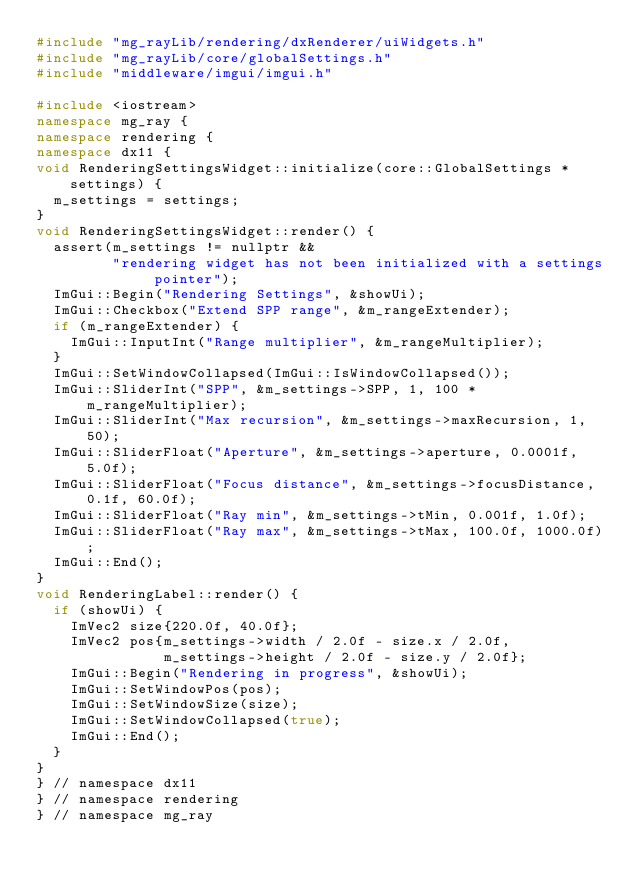<code> <loc_0><loc_0><loc_500><loc_500><_C++_>#include "mg_rayLib/rendering/dxRenderer/uiWidgets.h"
#include "mg_rayLib/core/globalSettings.h"
#include "middleware/imgui/imgui.h"

#include <iostream>
namespace mg_ray {
namespace rendering {
namespace dx11 {
void RenderingSettingsWidget::initialize(core::GlobalSettings *settings) {
  m_settings = settings;
}
void RenderingSettingsWidget::render() {
  assert(m_settings != nullptr &&
         "rendering widget has not been initialized with a settings pointer");
  ImGui::Begin("Rendering Settings", &showUi);
  ImGui::Checkbox("Extend SPP range", &m_rangeExtender);
  if (m_rangeExtender) {
    ImGui::InputInt("Range multiplier", &m_rangeMultiplier);
  }
  ImGui::SetWindowCollapsed(ImGui::IsWindowCollapsed());
  ImGui::SliderInt("SPP", &m_settings->SPP, 1, 100 * m_rangeMultiplier);
  ImGui::SliderInt("Max recursion", &m_settings->maxRecursion, 1, 50);
  ImGui::SliderFloat("Aperture", &m_settings->aperture, 0.0001f, 5.0f);
  ImGui::SliderFloat("Focus distance", &m_settings->focusDistance, 0.1f, 60.0f);
  ImGui::SliderFloat("Ray min", &m_settings->tMin, 0.001f, 1.0f);
  ImGui::SliderFloat("Ray max", &m_settings->tMax, 100.0f, 1000.0f);
  ImGui::End();
}
void RenderingLabel::render() {
  if (showUi) {
    ImVec2 size{220.0f, 40.0f};
    ImVec2 pos{m_settings->width / 2.0f - size.x / 2.0f,
               m_settings->height / 2.0f - size.y / 2.0f};
    ImGui::Begin("Rendering in progress", &showUi);
    ImGui::SetWindowPos(pos);
    ImGui::SetWindowSize(size);
    ImGui::SetWindowCollapsed(true);
    ImGui::End();
  }
}
} // namespace dx11
} // namespace rendering
} // namespace mg_ray
</code> 